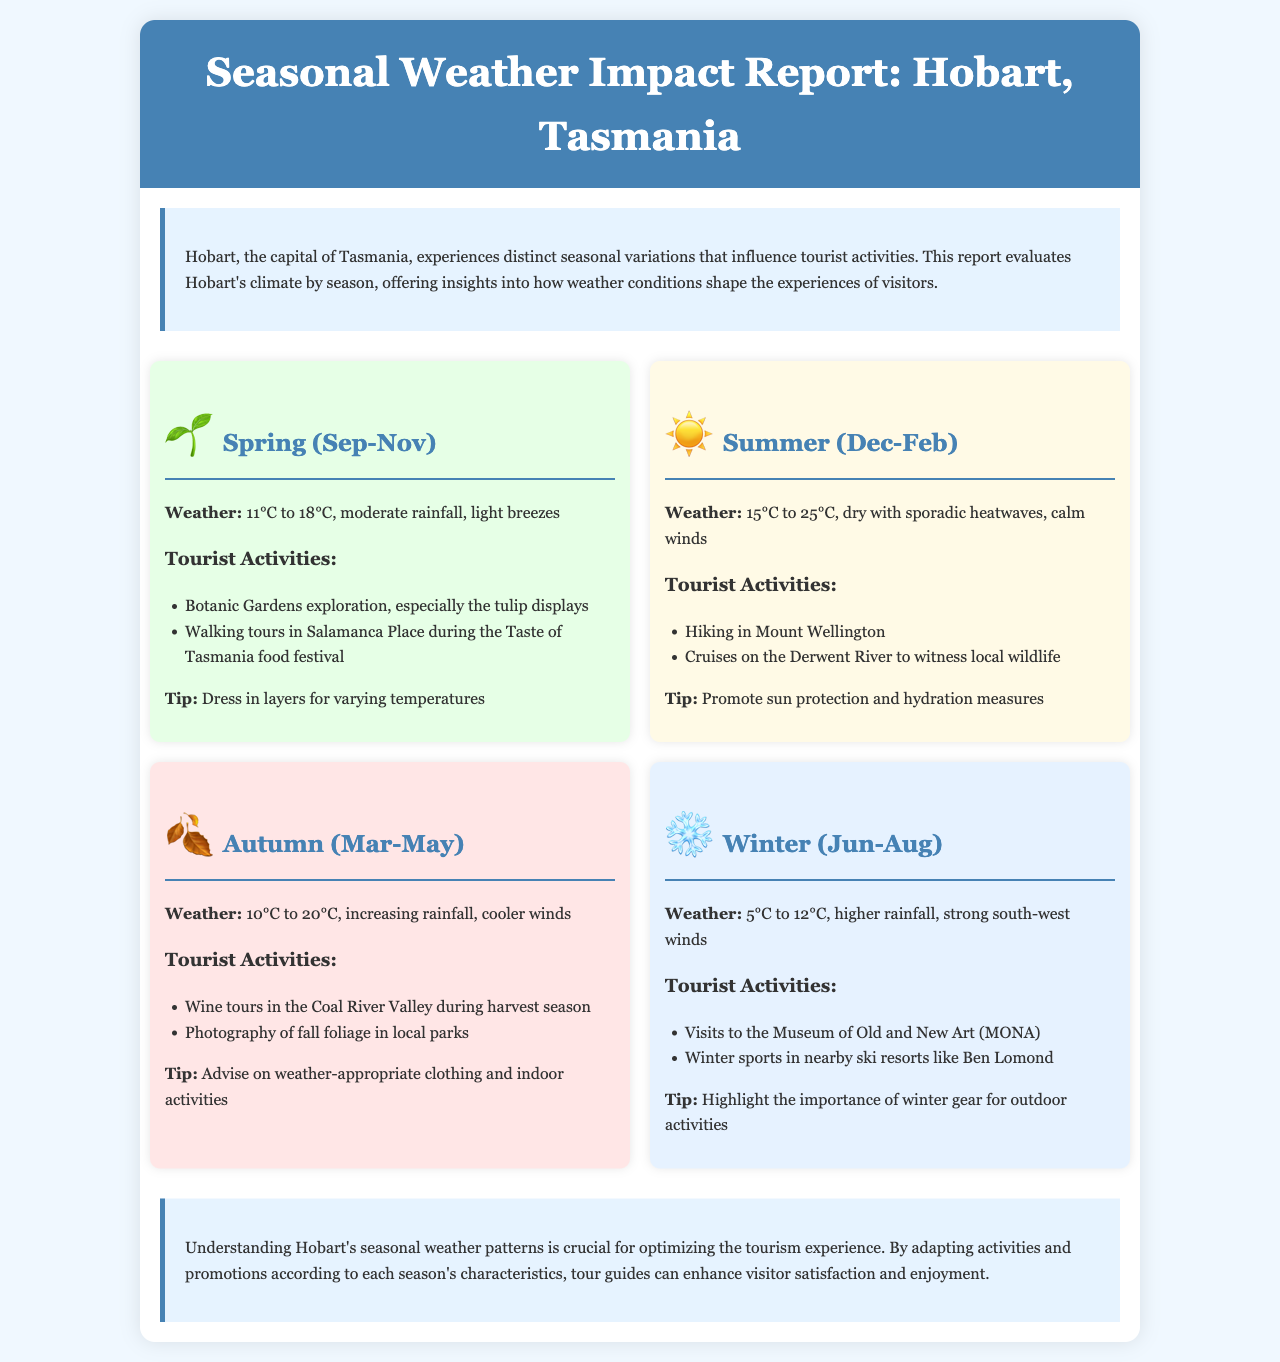What are the spring months in Hobart? The spring months in Hobart are September, October, and November, as indicated in the season section.
Answer: September-November What is the temperature range in summer? The summer temperature range is between 15°C to 25°C, as detailed in the summer weather section.
Answer: 15°C to 25°C What activities are suggested for autumn? Suggested activities for autumn include wine tours in the Coal River Valley and photography of fall foliage, as listed under autumn tourist activities.
Answer: Wine tours, Photography What is a notable tip for winter visitors? A notable tip for winter visitors is to highlight the importance of winter gear for outdoor activities, as mentioned in the winter section.
Answer: Winter gear How many degrees cooler is winter compared to summer? The winter temperature range is 5°C to 12°C, while summer is 15°C to 25°C. The average temperature difference can be calculated as 15°C - 5°C = 10°C.
Answer: 10°C Which season has the highest rainfall? Winter has the highest rainfall, as indicated in the winter weather description compared to other seasons.
Answer: Winter What is one event during spring? One event during spring is the Taste of Tasmania food festival, which is highlighted for walking tours in Salamanca Place.
Answer: Taste of Tasmania food festival Which months mark the autumn season? The autumn months are March, April, and May, as specified in the season section.
Answer: March-May What is the theme of the report? The theme of the report focuses on evaluating Hobart's climate by season and how weather conditions affect tourist activities.
Answer: Seasonal weather impact 